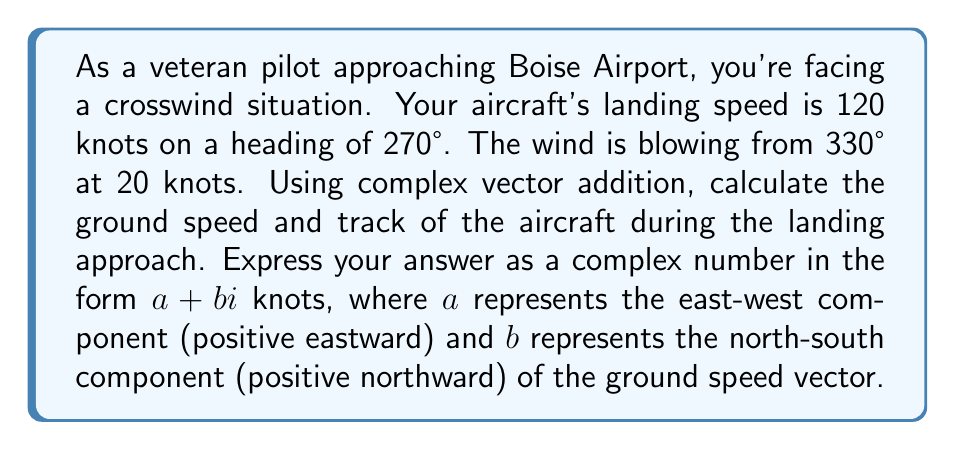Give your solution to this math problem. Let's approach this problem step by step using complex numbers:

1) First, we need to convert the given information into complex numbers. We'll use the convention that east is the positive real axis and north is the positive imaginary axis.

2) Aircraft velocity:
   - Speed: 120 knots
   - Direction: 270° (west)
   - As a complex number: $v_a = -120 + 0i$ knots

3) Wind velocity:
   - Speed: 20 knots
   - Direction: 330° (from northwest)
   - We need to consider the opposite direction (150°) as this is the direction the wind is pushing the aircraft
   - As a complex number: $v_w = 20 \cos 150° + 20i \sin 150°$ knots
   
4) Calculate wind vector:
   $$v_w = 20 \cos 150° + 20i \sin 150° = -17.32 - 10i$$ knots

5) The ground speed vector is the sum of the aircraft velocity and wind velocity:
   $$v_g = v_a + v_w = (-120 + 0i) + (-17.32 - 10i) = -137.32 - 10i$$ knots

6) This complex number represents the ground speed vector, where:
   - The real part (-137.32) is the east-west component (negative means westward)
   - The imaginary part (-10) is the north-south component (negative means southward)

7) The magnitude of this vector (actual ground speed) can be calculated as:
   $$\sqrt{(-137.32)^2 + (-10)^2} \approx 137.67$$ knots

8) The direction (track) can be calculated as:
   $$\arctan\left(\frac{-10}{-137.32}\right) \approx 4.17°$$ south of west
Answer: $-137.32 - 10i$ knots 